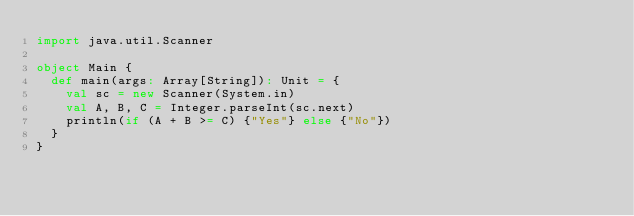Convert code to text. <code><loc_0><loc_0><loc_500><loc_500><_Scala_>import java.util.Scanner

object Main {
  def main(args: Array[String]): Unit = {
    val sc = new Scanner(System.in)
    val A, B, C = Integer.parseInt(sc.next)
    println(if (A + B >= C) {"Yes"} else {"No"})
  }
}</code> 